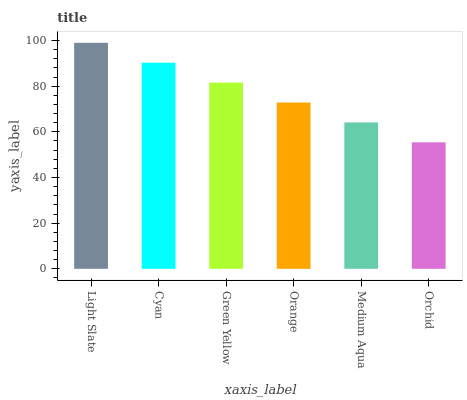Is Orchid the minimum?
Answer yes or no. Yes. Is Light Slate the maximum?
Answer yes or no. Yes. Is Cyan the minimum?
Answer yes or no. No. Is Cyan the maximum?
Answer yes or no. No. Is Light Slate greater than Cyan?
Answer yes or no. Yes. Is Cyan less than Light Slate?
Answer yes or no. Yes. Is Cyan greater than Light Slate?
Answer yes or no. No. Is Light Slate less than Cyan?
Answer yes or no. No. Is Green Yellow the high median?
Answer yes or no. Yes. Is Orange the low median?
Answer yes or no. Yes. Is Cyan the high median?
Answer yes or no. No. Is Cyan the low median?
Answer yes or no. No. 